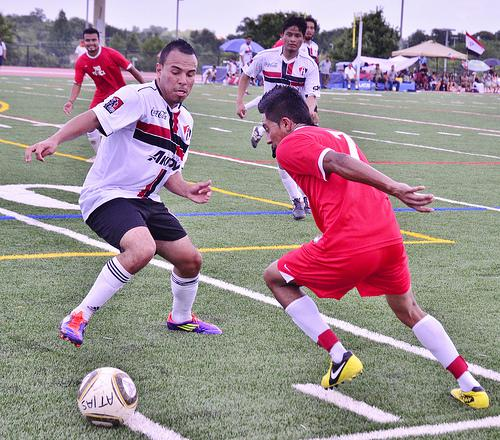Question: what game are the men playing?
Choices:
A. Kickball.
B. Football.
C. Soccer.
D. Tennis.
Answer with the letter. Answer: C Question: where is the ball?
Choices:
A. In the glove.
B. On the ground.
C. Flying through the air.
D. In a basket.
Answer with the letter. Answer: B Question: what are they playing on?
Choices:
A. Grass.
B. Dirt.
C. AstroTurf.
D. Concrete.
Answer with the letter. Answer: A Question: how many teams are there?
Choices:
A. 1.
B. 2.
C. 3.
D. 5.
Answer with the letter. Answer: B Question: why are they going to kick the ball?
Choices:
A. To start the game.
B. To score a field goal.
C. So the other team can catch it.
D. To get it in the goal.
Answer with the letter. Answer: D Question: who is wearing yellow shoes?
Choices:
A. Number 7.
B. Number 12.
C. Number 20.
D. Number 1.
Answer with the letter. Answer: A 